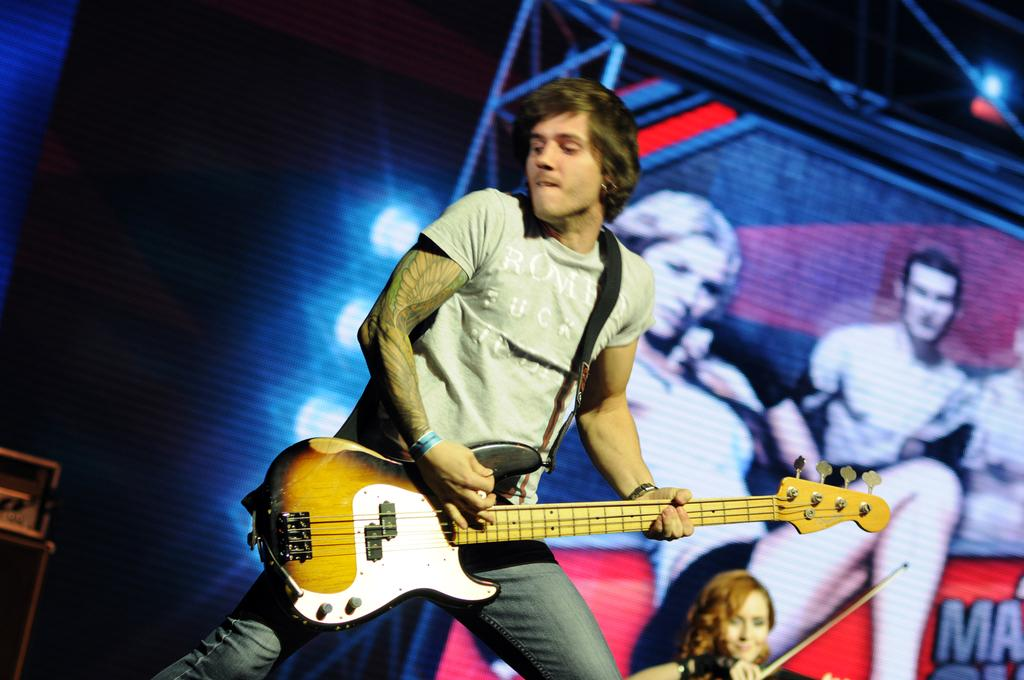What is the person in the image wearing? The person in the image is wearing a grey t-shirt. What is the person doing in the image? The person is holding and playing a guitar. Can you describe the woman in the background of the image? The woman in the background is playing a violin. What can be seen in the background of the image besides the woman? There is a hoarding and light visible in the background, as well as other items. What type of baseball equipment can be seen in the image? There is no baseball equipment present in the image. Can you describe the foggy conditions in the image? There is no fog present in the image; it is clear and well-lit. 